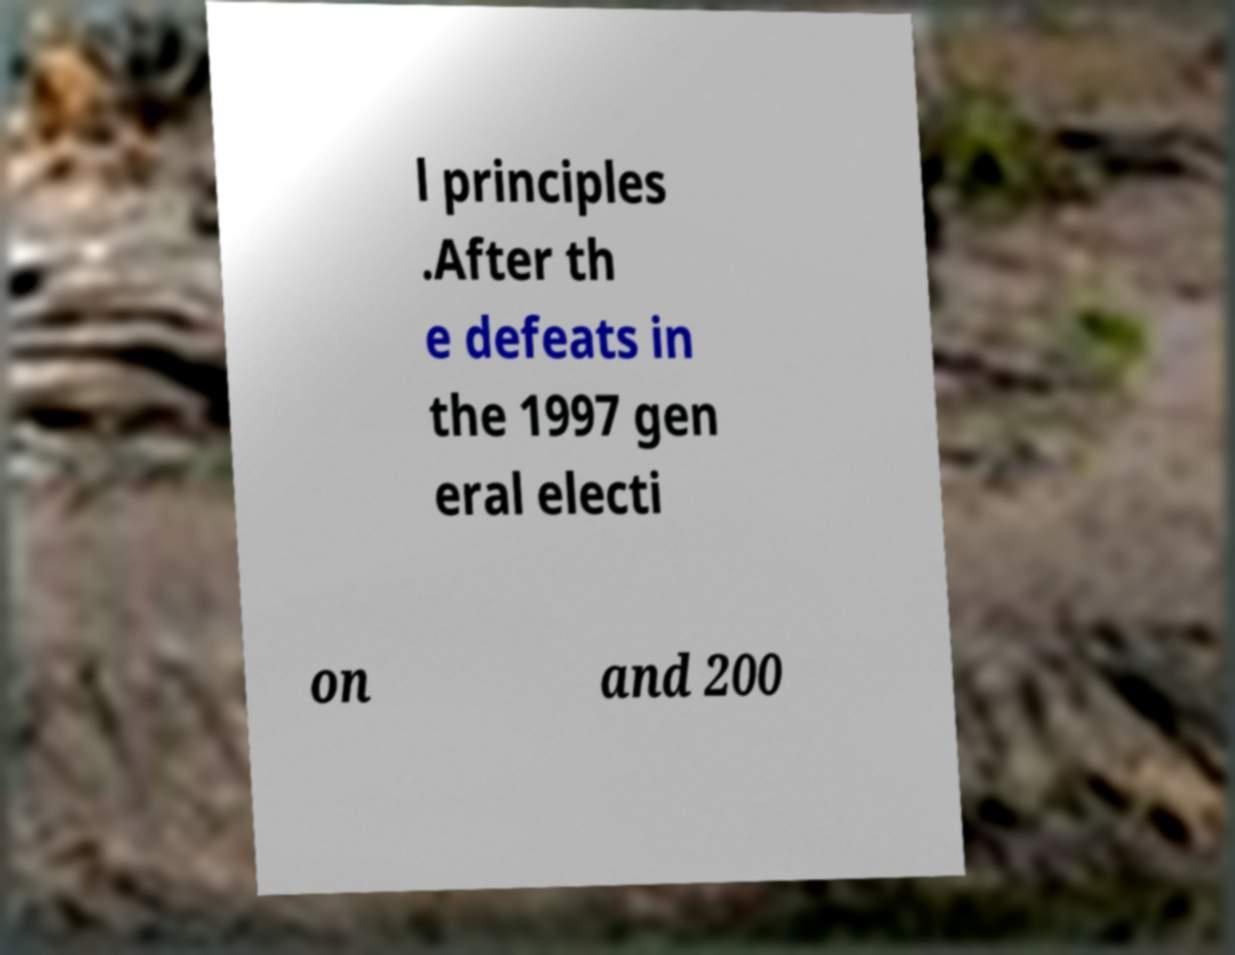Can you accurately transcribe the text from the provided image for me? l principles .After th e defeats in the 1997 gen eral electi on and 200 